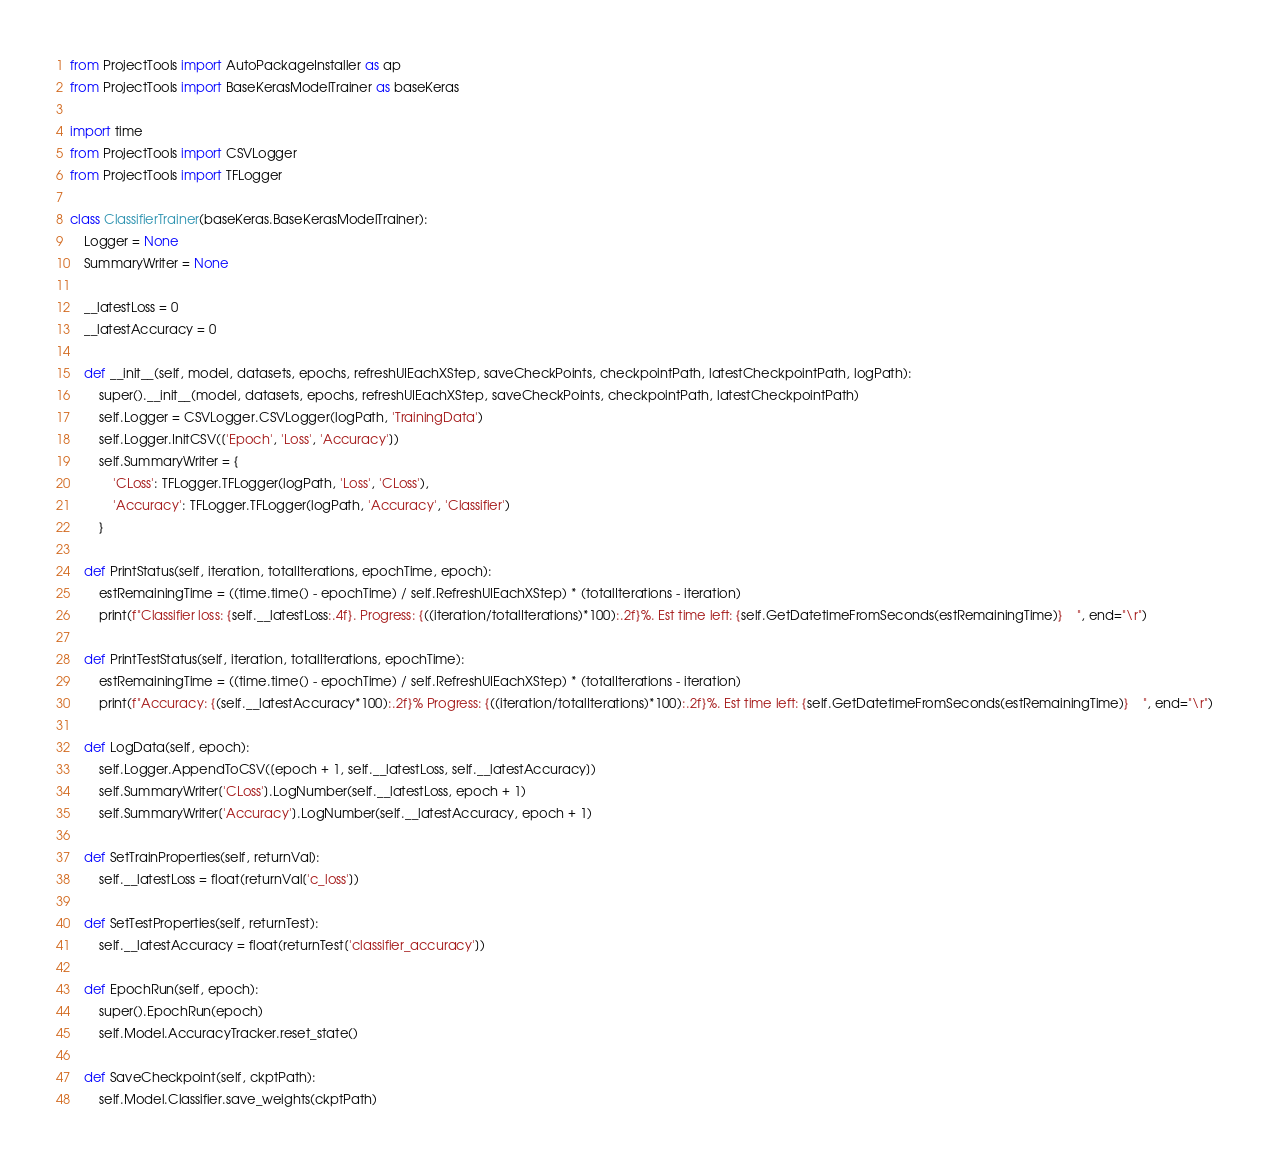<code> <loc_0><loc_0><loc_500><loc_500><_Python_>from ProjectTools import AutoPackageInstaller as ap
from ProjectTools import BaseKerasModelTrainer as baseKeras

import time
from ProjectTools import CSVLogger
from ProjectTools import TFLogger

class ClassifierTrainer(baseKeras.BaseKerasModelTrainer):
    Logger = None
    SummaryWriter = None

    __latestLoss = 0
    __latestAccuracy = 0

    def __init__(self, model, datasets, epochs, refreshUIEachXStep, saveCheckPoints, checkpointPath, latestCheckpointPath, logPath):
        super().__init__(model, datasets, epochs, refreshUIEachXStep, saveCheckPoints, checkpointPath, latestCheckpointPath)
        self.Logger = CSVLogger.CSVLogger(logPath, 'TrainingData')
        self.Logger.InitCSV(['Epoch', 'Loss', 'Accuracy'])
        self.SummaryWriter = {
            'CLoss': TFLogger.TFLogger(logPath, 'Loss', 'CLoss'),
            'Accuracy': TFLogger.TFLogger(logPath, 'Accuracy', 'Classifier')
        }

    def PrintStatus(self, iteration, totalIterations, epochTime, epoch):
        estRemainingTime = ((time.time() - epochTime) / self.RefreshUIEachXStep) * (totalIterations - iteration)
        print(f"Classifier loss: {self.__latestLoss:.4f}. Progress: {((iteration/totalIterations)*100):.2f}%. Est time left: {self.GetDatetimeFromSeconds(estRemainingTime)}    ", end="\r")

    def PrintTestStatus(self, iteration, totalIterations, epochTime):
        estRemainingTime = ((time.time() - epochTime) / self.RefreshUIEachXStep) * (totalIterations - iteration)
        print(f"Accuracy: {(self.__latestAccuracy*100):.2f}% Progress: {((iteration/totalIterations)*100):.2f}%. Est time left: {self.GetDatetimeFromSeconds(estRemainingTime)}    ", end="\r")
        
    def LogData(self, epoch):
        self.Logger.AppendToCSV([epoch + 1, self.__latestLoss, self.__latestAccuracy])
        self.SummaryWriter['CLoss'].LogNumber(self.__latestLoss, epoch + 1)
        self.SummaryWriter['Accuracy'].LogNumber(self.__latestAccuracy, epoch + 1)

    def SetTrainProperties(self, returnVal):
        self.__latestLoss = float(returnVal['c_loss'])

    def SetTestProperties(self, returnTest):
        self.__latestAccuracy = float(returnTest['classifier_accuracy'])

    def EpochRun(self, epoch):
        super().EpochRun(epoch)
        self.Model.AccuracyTracker.reset_state()

    def SaveCheckpoint(self, ckptPath):
        self.Model.Classifier.save_weights(ckptPath)</code> 